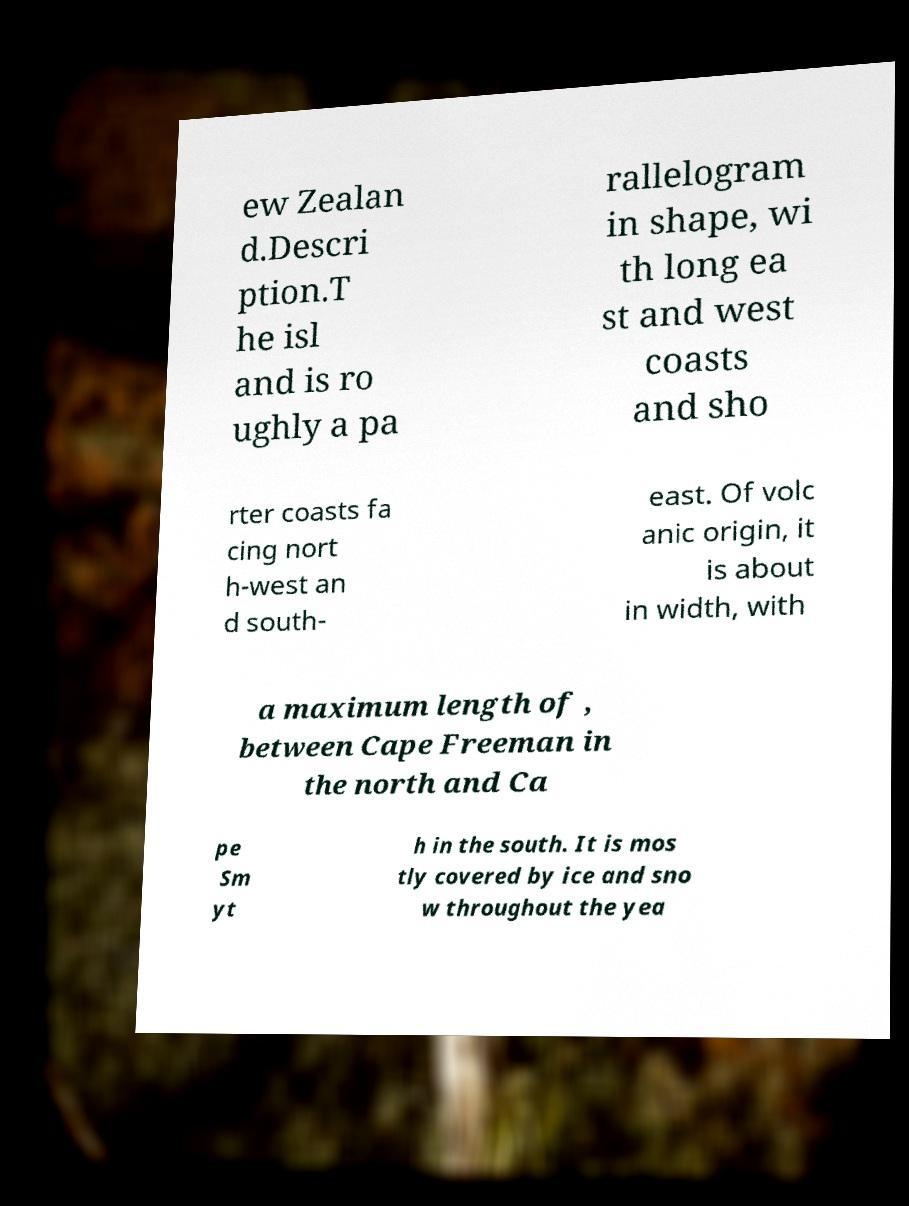Please identify and transcribe the text found in this image. ew Zealan d.Descri ption.T he isl and is ro ughly a pa rallelogram in shape, wi th long ea st and west coasts and sho rter coasts fa cing nort h-west an d south- east. Of volc anic origin, it is about in width, with a maximum length of , between Cape Freeman in the north and Ca pe Sm yt h in the south. It is mos tly covered by ice and sno w throughout the yea 